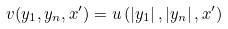<formula> <loc_0><loc_0><loc_500><loc_500>v ( y _ { 1 } , y _ { n } , x ^ { \prime } ) = u \left ( \left | y _ { 1 } \right | , \left | y _ { n } \right | , x ^ { \prime } \right )</formula> 